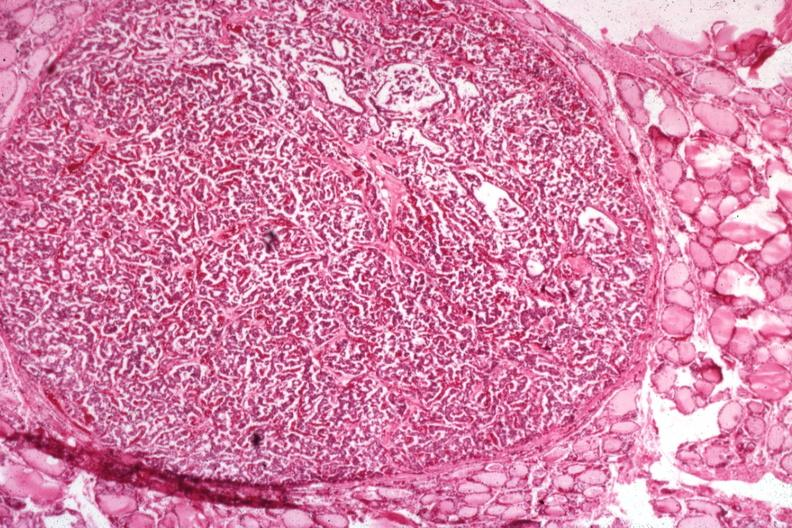s papillary adenoma present?
Answer the question using a single word or phrase. Yes 